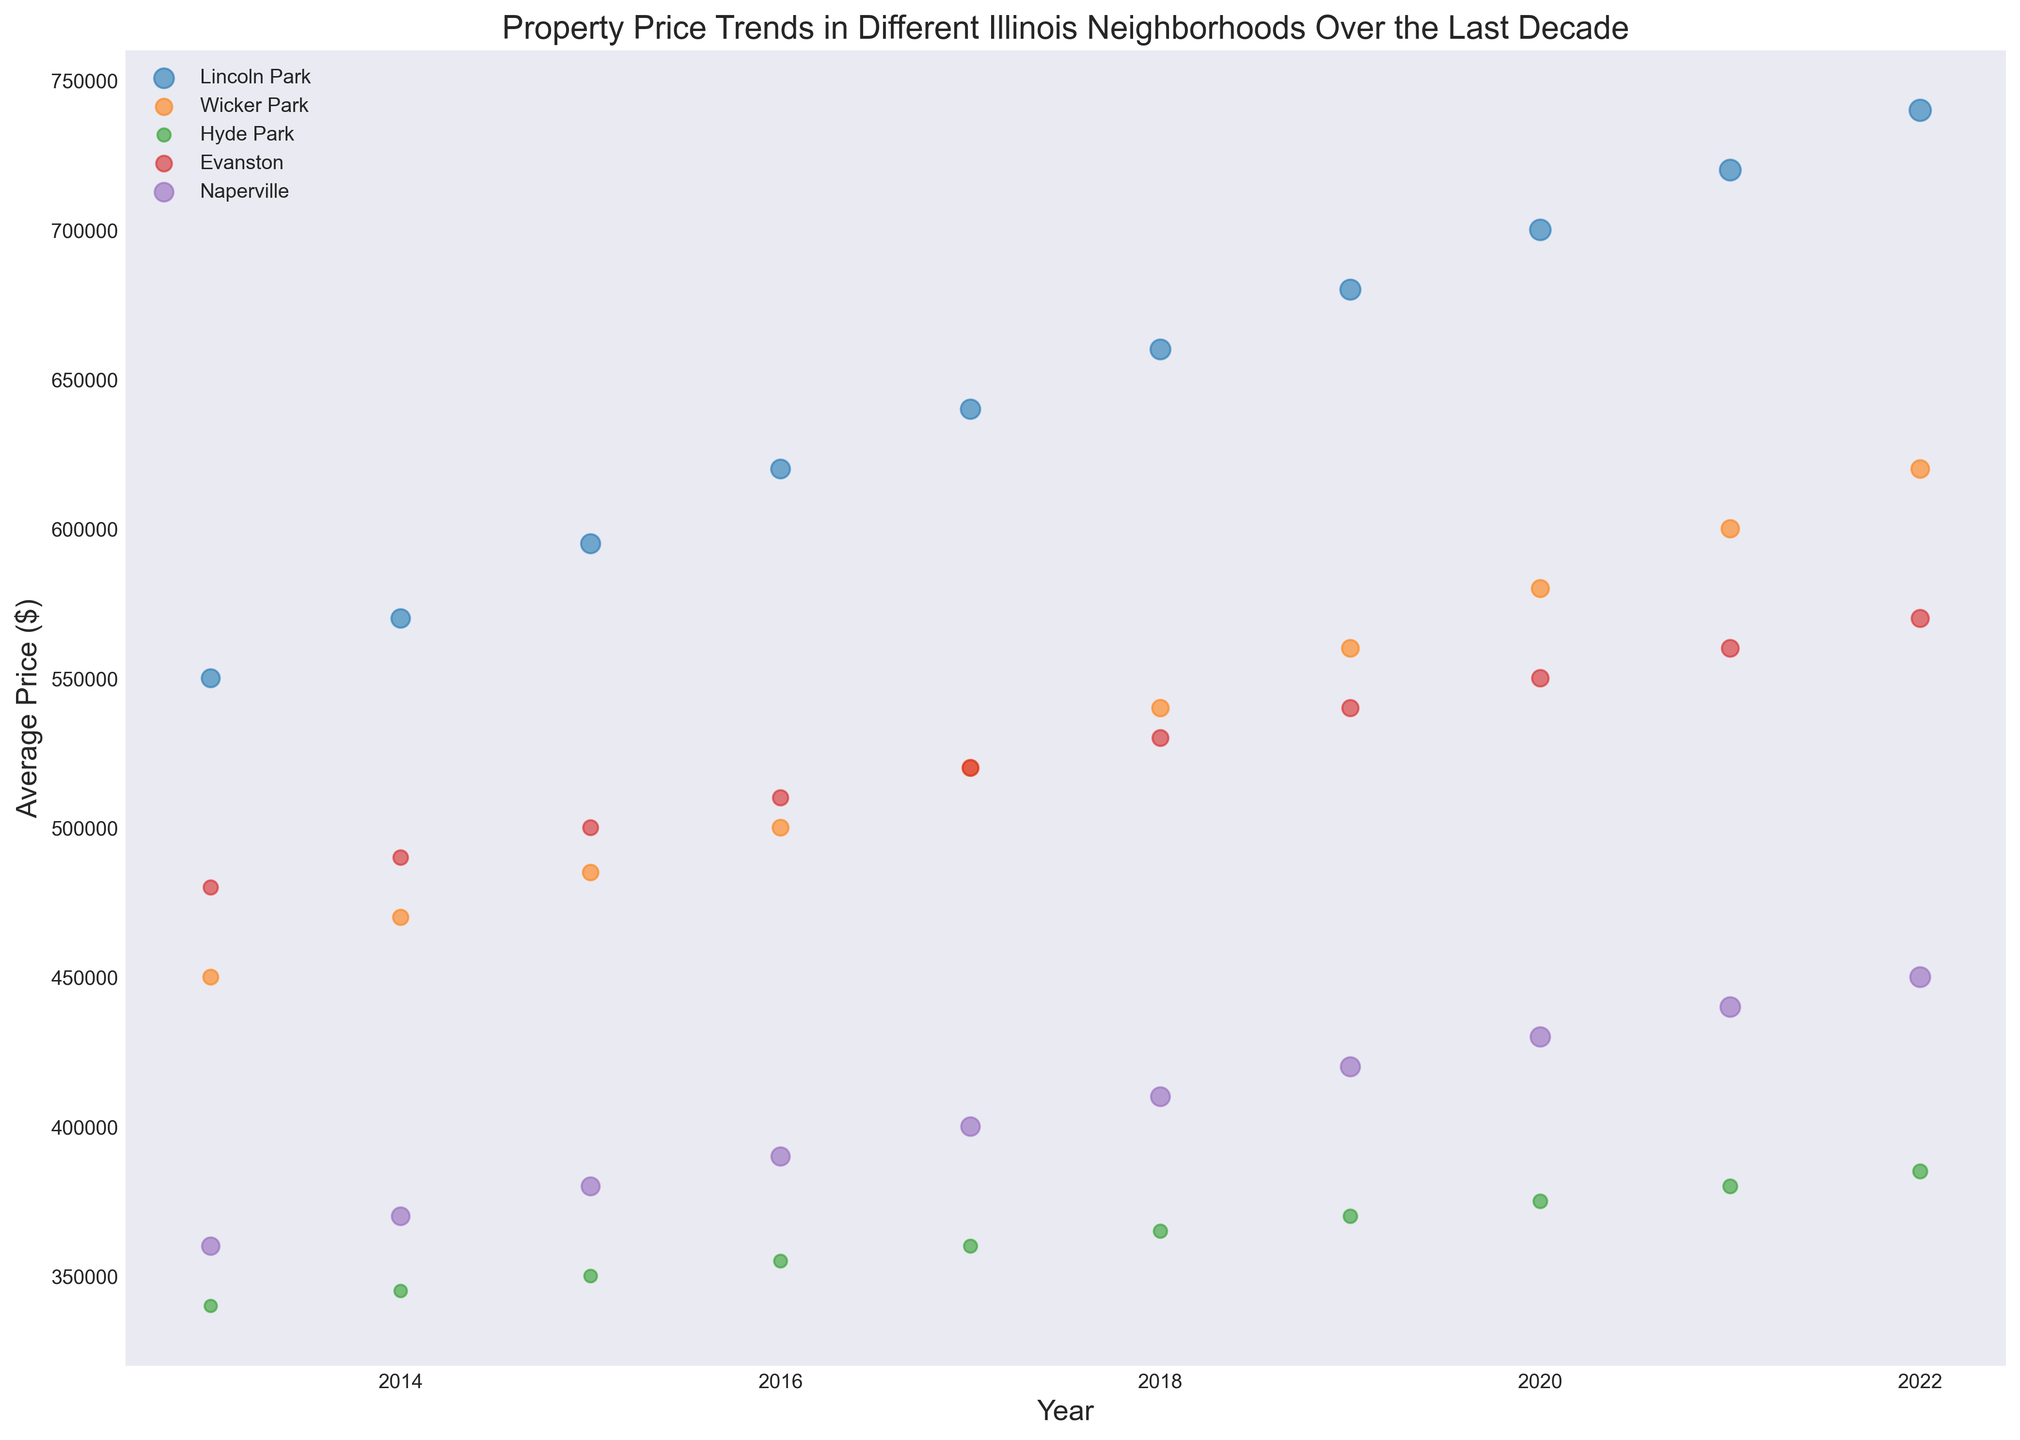Which neighborhood has the highest average property price in 2022? The figure shows average property prices for each neighborhood in 2022. Lincoln Park has the highest price, represented by the highest point in the respective year.
Answer: Lincoln Park Between Hyde Park and Evanston, which neighborhood had more sales in 2018? Looking at the bubble sizes for 2018, the bubble for Evanston is larger than that for Hyde Park, indicating more sales.
Answer: Evanston What was the average property price increase for Naperville from 2015 to 2020? To find the increase, look at the average property prices in 2015 and 2020 for Naperville and find the difference: $430,000 - $380,000 = $50,000.
Answer: $50,000 Which neighborhood shows the most consistent increase in average property price from 2013 to 2022? Consistent increase can be determined by a steady upward trend in prices. Evanston appears to show a steady linear increase without any dips or plateaus.
Answer: Evanston How does the number of sales in Wicker Park in 2019 compare to 2022? Compare the bubble sizes for Wicker Park in 2019 and 2022. The bubble in 2022 is larger, indicating more sales.
Answer: More in 2022 Which year did Lincoln Park experience the sharpest increase in average property price? The sharpest increase can be identified by the steepest slope between two consecutive years. From 2019 to 2020, the slope is steepest, indicating the sharpest increase.
Answer: 2020 If you consider both the number of sales and average price, which neighborhood seems the most favorable in 2022? Lincoln Park not only has the highest average property price but also the largest bubble, indicating the highest number of sales, making it the most favorable.
Answer: Lincoln Park What is the approximate range of average property prices in Hyde Park from 2013 to 2022? The range can be calculated by subtracting the lowest price in 2013 from the highest price in 2022 in Hyde Park: $385,000 - $340,000 = $45,000.
Answer: $45,000 Which two neighborhoods have the closest average property price in 2022? Finding neighborhoods with similar prices in 2022, Wicker Park and Evanston both show average prices around $620,000 and $570,000, respectively, being the closest.
Answer: Wicker Park and Evanston 